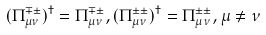<formula> <loc_0><loc_0><loc_500><loc_500>( \Pi ^ { \mp \pm } _ { \mu \nu } ) ^ { \dag } = \Pi ^ { \mp \pm } _ { \mu \nu } , ( \Pi ^ { \pm \pm } _ { \mu \nu } ) ^ { \dag } = \Pi ^ { \pm \pm } _ { \mu \nu } , \mu \neq \nu</formula> 